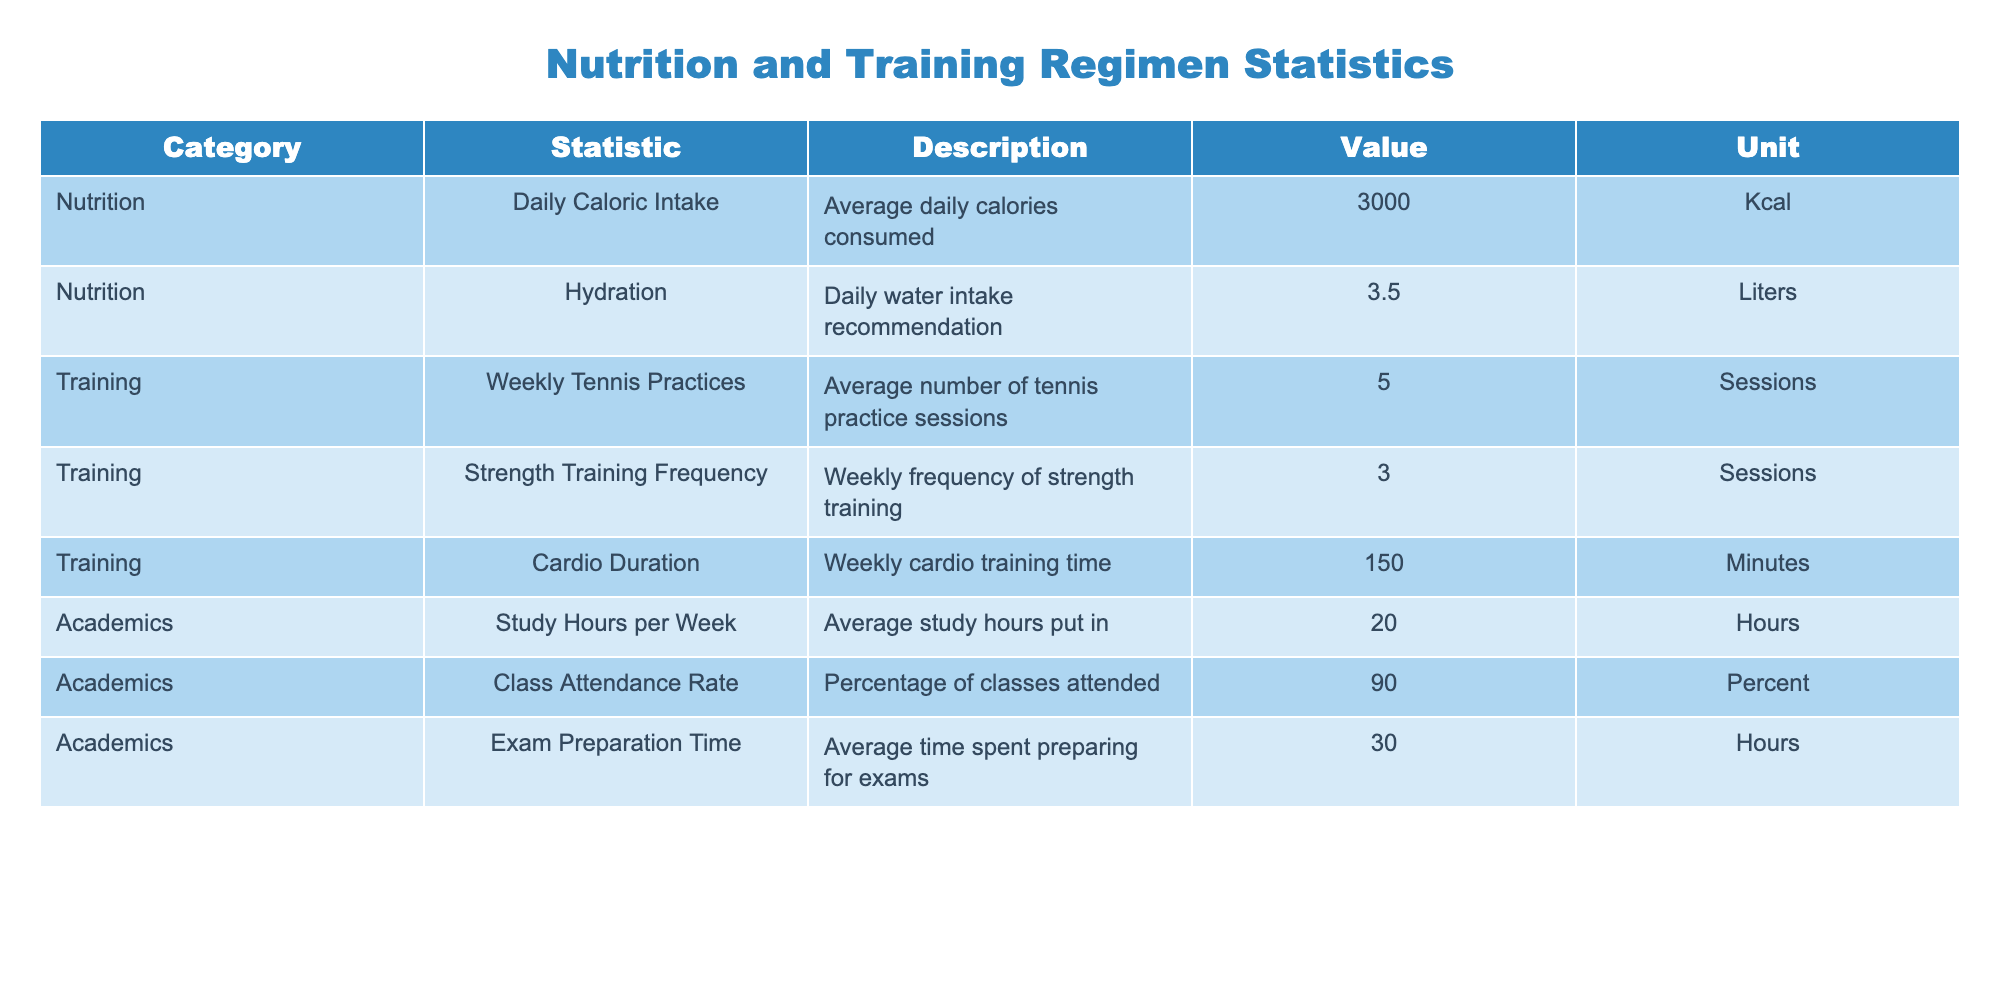What is the average daily caloric intake? The table shows that the average daily caloric intake is listed directly, which is 3000 Kcal.
Answer: 3000 Kcal How many strength training sessions do you have per week? The table directly states the weekly frequency of strength training sessions, which is 3.
Answer: 3 sessions Is the class attendance rate above 85 percent? The class attendance rate given in the table is 90 percent, which is indeed above 85 percent, confirming a yes answer.
Answer: Yes What is the total time spent on cardio training each week and how does it compare to the study hours? The total time spent on cardio training each week is 150 minutes. To compare this with study hours, convert 20 hours to minutes (20 hours * 60 minutes/hour = 1200 minutes). 150 minutes is much less than 1200 minutes of study hours. So, the comparison shows that there is significantly more time spent on studying than on cardio training.
Answer: Less than study hours What is the total average preparation time for exams if you have exams every month? The average exam preparation time in the table is 30 hours. If exams occur monthly, then for a year (12 months), the total preparation time would be 30 hours * 12 months = 360 hours. This calculation shows the total time devoted to exam preparation over a year.
Answer: 360 hours What is the combined weekly frequency of tennis practices and strength training sessions? The weekly tennis practices are recorded at 5 sessions, while the strength training frequency is 3 sessions. To find the combined weekly frequency, we sum them (5 + 3 = 8). Therefore, the total is 8 sessions.
Answer: 8 sessions Is the hydration recommendation above 4 liters? The hydration recommendation in the table is 3.5 liters. Comparing this with 4 liters shows that 3.5 liters is less than 4. Therefore, the answer is no.
Answer: No What percentage of classes do you miss if you have a class attendance rate of 90 percent? A class attendance rate of 90 percent indicates that you miss 100 - 90 = 10 percent of classes. This calculation shows the percentage of classes missed based on the attendance rate provided.
Answer: 10 percent 